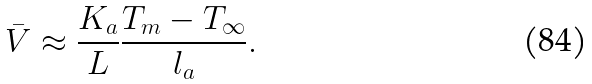<formula> <loc_0><loc_0><loc_500><loc_500>\bar { V } \approx \frac { K _ { a } } { L } \frac { T _ { m } - T _ { \infty } } { l _ { a } } .</formula> 